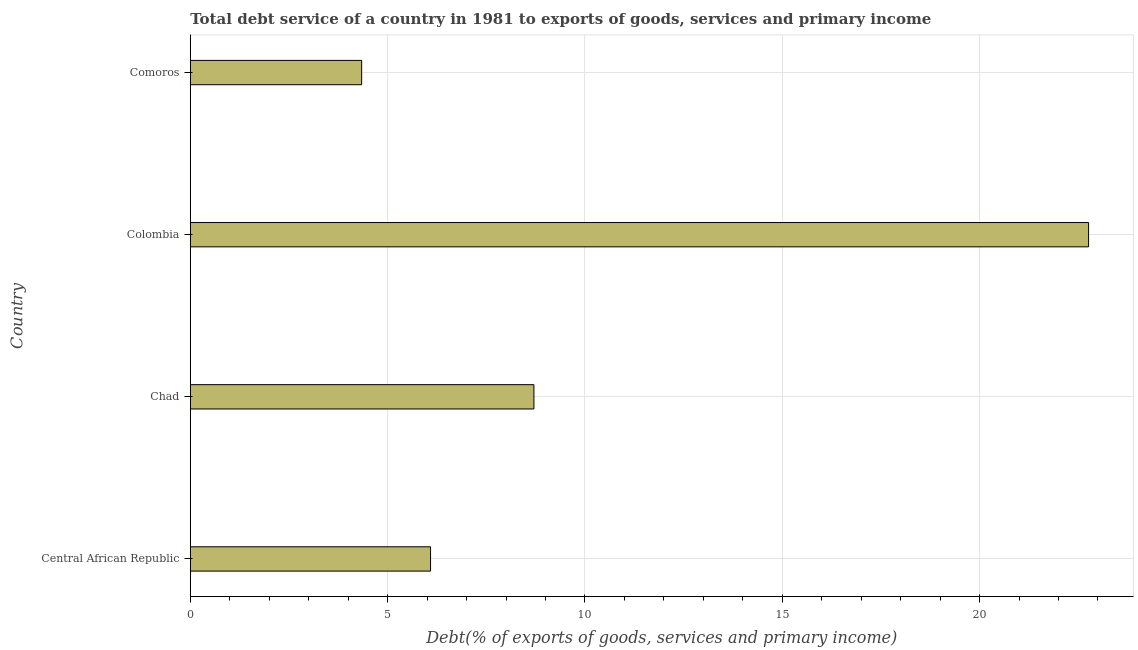What is the title of the graph?
Provide a short and direct response. Total debt service of a country in 1981 to exports of goods, services and primary income. What is the label or title of the X-axis?
Offer a terse response. Debt(% of exports of goods, services and primary income). What is the total debt service in Chad?
Offer a terse response. 8.71. Across all countries, what is the maximum total debt service?
Offer a very short reply. 22.76. Across all countries, what is the minimum total debt service?
Keep it short and to the point. 4.34. In which country was the total debt service minimum?
Your answer should be very brief. Comoros. What is the sum of the total debt service?
Provide a short and direct response. 41.9. What is the difference between the total debt service in Central African Republic and Comoros?
Provide a succinct answer. 1.75. What is the average total debt service per country?
Your answer should be compact. 10.47. What is the median total debt service?
Provide a succinct answer. 7.4. In how many countries, is the total debt service greater than 10 %?
Offer a terse response. 1. What is the ratio of the total debt service in Central African Republic to that in Colombia?
Give a very brief answer. 0.27. What is the difference between the highest and the second highest total debt service?
Offer a very short reply. 14.05. What is the difference between the highest and the lowest total debt service?
Your answer should be compact. 18.42. How many bars are there?
Offer a very short reply. 4. How many countries are there in the graph?
Provide a short and direct response. 4. What is the difference between two consecutive major ticks on the X-axis?
Your response must be concise. 5. What is the Debt(% of exports of goods, services and primary income) in Central African Republic?
Your answer should be very brief. 6.09. What is the Debt(% of exports of goods, services and primary income) in Chad?
Keep it short and to the point. 8.71. What is the Debt(% of exports of goods, services and primary income) of Colombia?
Provide a succinct answer. 22.76. What is the Debt(% of exports of goods, services and primary income) of Comoros?
Give a very brief answer. 4.34. What is the difference between the Debt(% of exports of goods, services and primary income) in Central African Republic and Chad?
Offer a very short reply. -2.62. What is the difference between the Debt(% of exports of goods, services and primary income) in Central African Republic and Colombia?
Give a very brief answer. -16.67. What is the difference between the Debt(% of exports of goods, services and primary income) in Central African Republic and Comoros?
Make the answer very short. 1.75. What is the difference between the Debt(% of exports of goods, services and primary income) in Chad and Colombia?
Provide a short and direct response. -14.05. What is the difference between the Debt(% of exports of goods, services and primary income) in Chad and Comoros?
Ensure brevity in your answer.  4.36. What is the difference between the Debt(% of exports of goods, services and primary income) in Colombia and Comoros?
Your answer should be very brief. 18.42. What is the ratio of the Debt(% of exports of goods, services and primary income) in Central African Republic to that in Chad?
Make the answer very short. 0.7. What is the ratio of the Debt(% of exports of goods, services and primary income) in Central African Republic to that in Colombia?
Your answer should be very brief. 0.27. What is the ratio of the Debt(% of exports of goods, services and primary income) in Central African Republic to that in Comoros?
Offer a very short reply. 1.4. What is the ratio of the Debt(% of exports of goods, services and primary income) in Chad to that in Colombia?
Provide a short and direct response. 0.38. What is the ratio of the Debt(% of exports of goods, services and primary income) in Chad to that in Comoros?
Ensure brevity in your answer.  2. What is the ratio of the Debt(% of exports of goods, services and primary income) in Colombia to that in Comoros?
Make the answer very short. 5.24. 